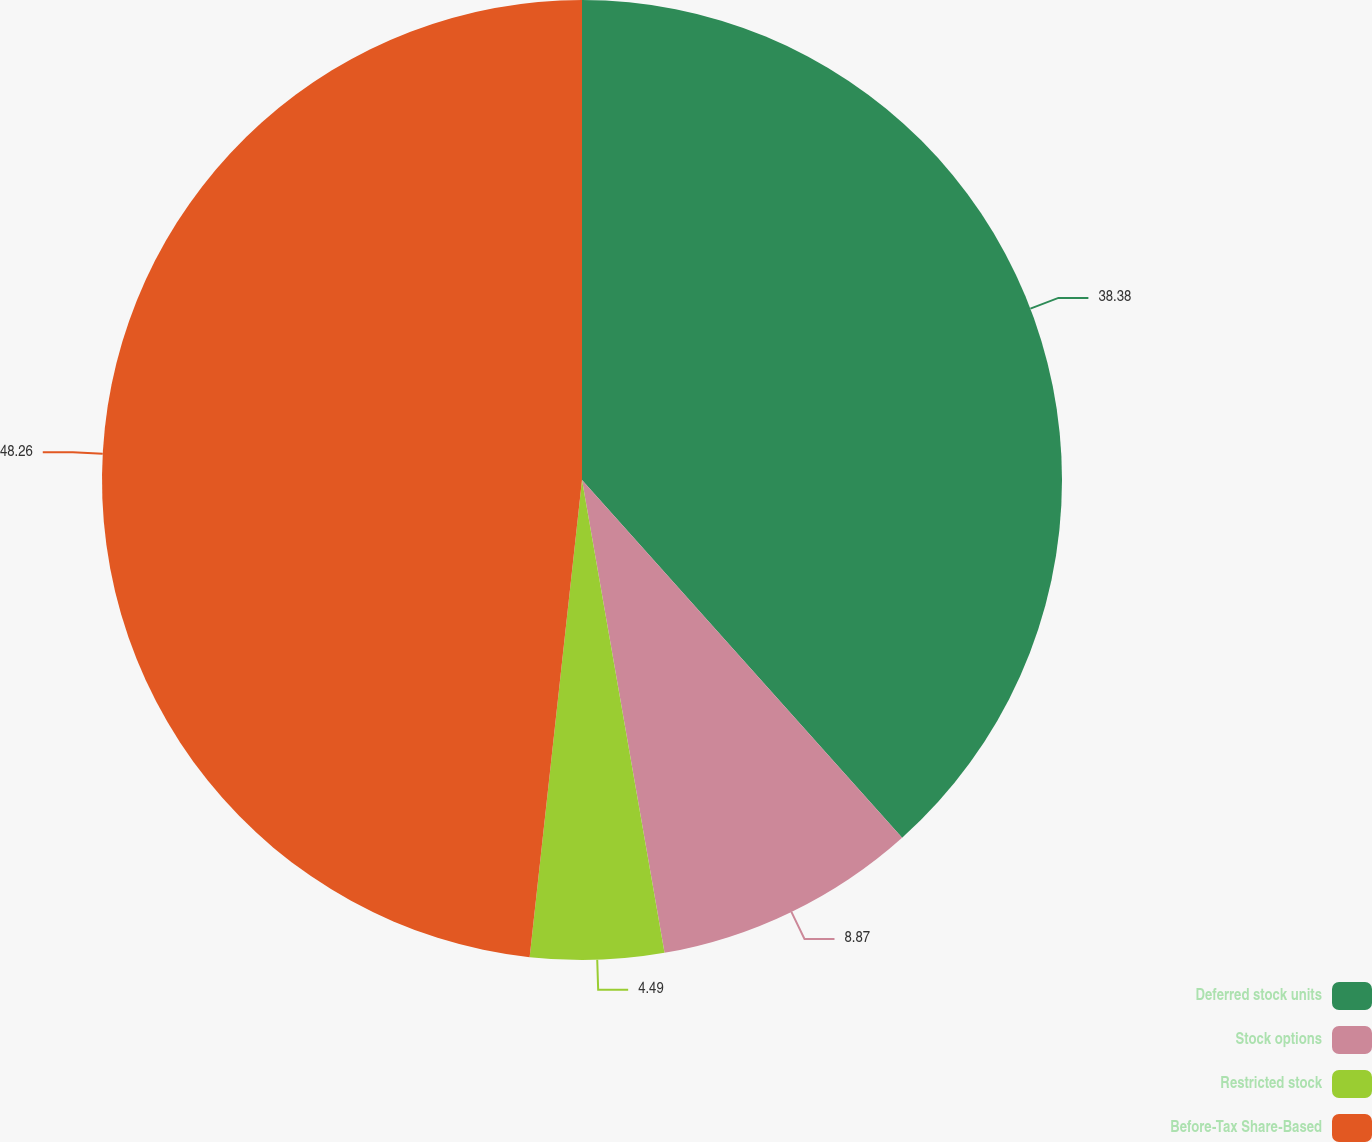<chart> <loc_0><loc_0><loc_500><loc_500><pie_chart><fcel>Deferred stock units<fcel>Stock options<fcel>Restricted stock<fcel>Before-Tax Share-Based<nl><fcel>38.38%<fcel>8.87%<fcel>4.49%<fcel>48.26%<nl></chart> 